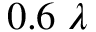Convert formula to latex. <formula><loc_0><loc_0><loc_500><loc_500>0 . 6 \, \lambda</formula> 